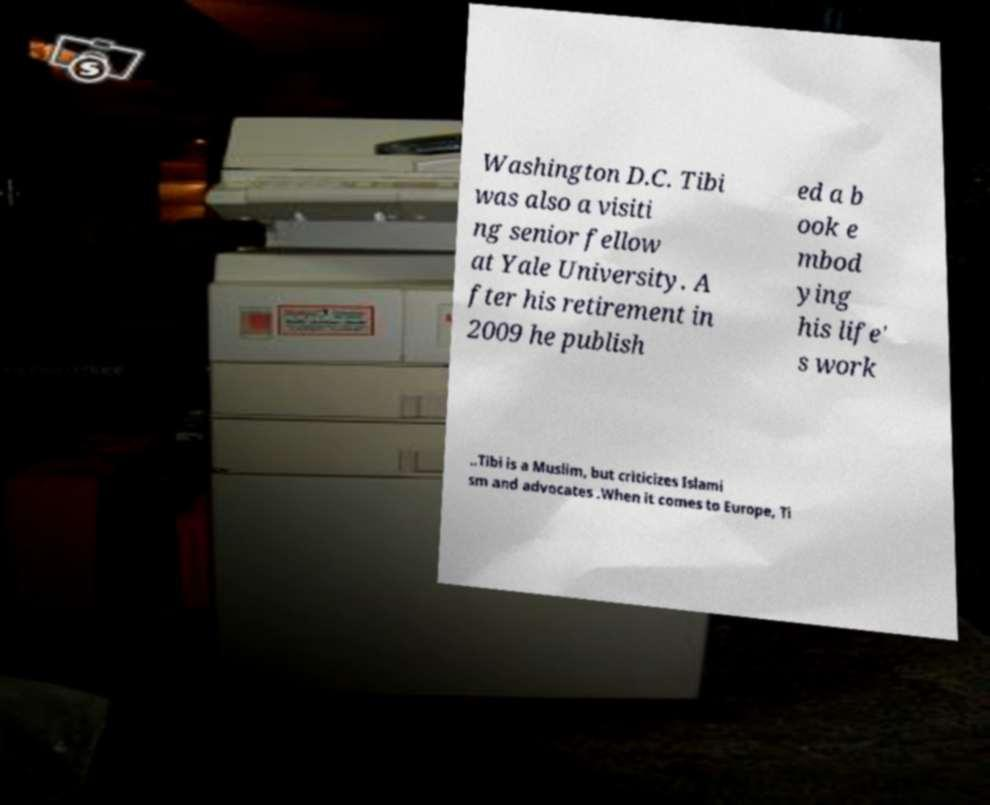What messages or text are displayed in this image? I need them in a readable, typed format. Washington D.C. Tibi was also a visiti ng senior fellow at Yale University. A fter his retirement in 2009 he publish ed a b ook e mbod ying his life' s work ..Tibi is a Muslim, but criticizes Islami sm and advocates .When it comes to Europe, Ti 